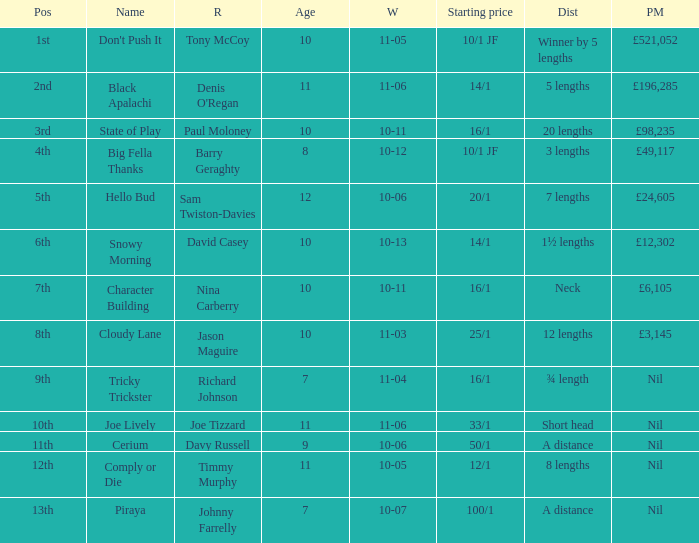 How much did Nina Carberry win?  £6,105. 